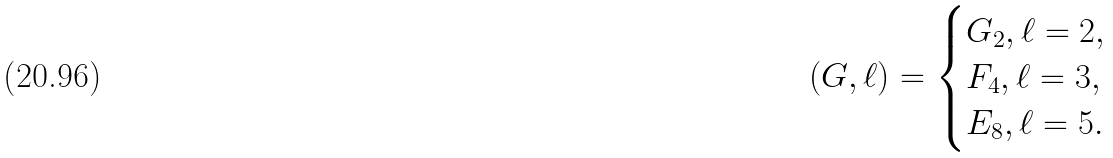Convert formula to latex. <formula><loc_0><loc_0><loc_500><loc_500>( G , \ell ) = \begin{cases} G _ { 2 } , \ell = 2 , \\ F _ { 4 } , \ell = 3 , \\ E _ { 8 } , \ell = 5 . \end{cases}</formula> 